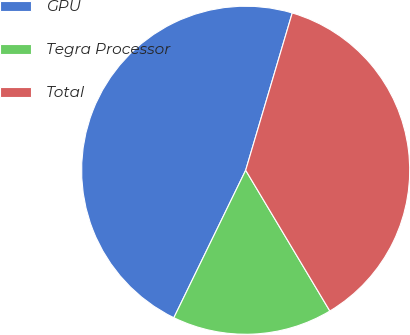Convert chart. <chart><loc_0><loc_0><loc_500><loc_500><pie_chart><fcel>GPU<fcel>Tegra Processor<fcel>Total<nl><fcel>47.37%<fcel>15.79%<fcel>36.84%<nl></chart> 